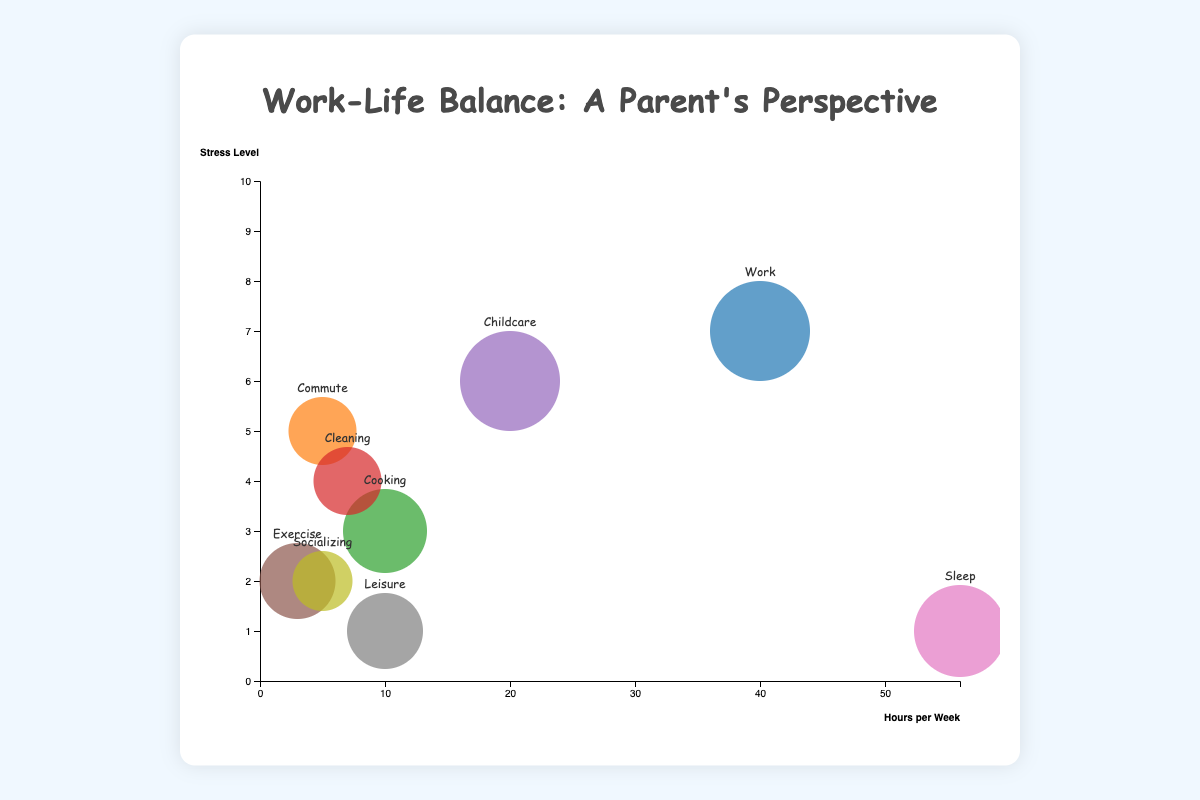Which activity has the highest stress level? The activity with the highest stress level can be identified by locating the bubble positioned the highest on the y-axis. The “Work” bubble is highest with a stress level of 7.
Answer: Work Which activity occupies the most hours per week? The activity occupying the most hours per week can be found by looking for the bubble farthest to the right on the x-axis. The “Sleep” bubble is farthest to the right with 56 hours per week.
Answer: Sleep How many activities have a stress level less than 3? Find all bubbles positioned below the y-value of 3. There are three bubbles labeled “Sleep,” “Exercise,” and “Leisure.”
Answer: 3 activities (Sleep, Exercise, Leisure) Compare the stress levels of “Work” and “Childcare.” Which one is higher? Locate both the “Work” and “Childcare” bubbles and read their stress levels from the y-axis. “Work” has a stress level of 7, and “Childcare” has a stress level of 6. Thus, “Work” has a higher stress level.
Answer: Work Which activity has the highest importance? The activity with the highest importance will have the largest bubble size. The bubble for “Work” is the largest with an importance of 10.
Answer: Work Which activities have the same hours per week? Identify bubbles that align vertically at the same x-axis value. “Leisure” and “Cooking” both align at 10 hours per week.
Answer: Leisure and Cooking What is the combined total of hours spent on “Commute” and “Socializing” per week? Add the hours per week for both activities. “Commute” has 5 hours and “Socializing” has 5 hours, so the total is 5 + 5 = 10 hours.
Answer: 10 hours How does the importance of “Exercise” compare to “Cleaning”? Compare the bubble sizes, where “Exercise” has an importance of 7 and “Cleaning” has 6. Thus, “Exercise” is more important.
Answer: Exercise Is there any activity that has a stress level of 1 and also occupies 10 hours per week? Look for a bubble at the intersection of y-axis value 1 and x-axis value 10. The “Leisure” bubble fits this criteria.
Answer: Leisure What is the average importance of the activities with less than 10 hours per week? Identify and sum the importance values for activities with less than 10 hours per week; these are “Commute” (6), “Exercise” (7), “Socializing” (5), and “Cleaning” (6). Average by dividing the sum by the number of activities: (6+7+5+6)/4 = 6.
Answer: 6 